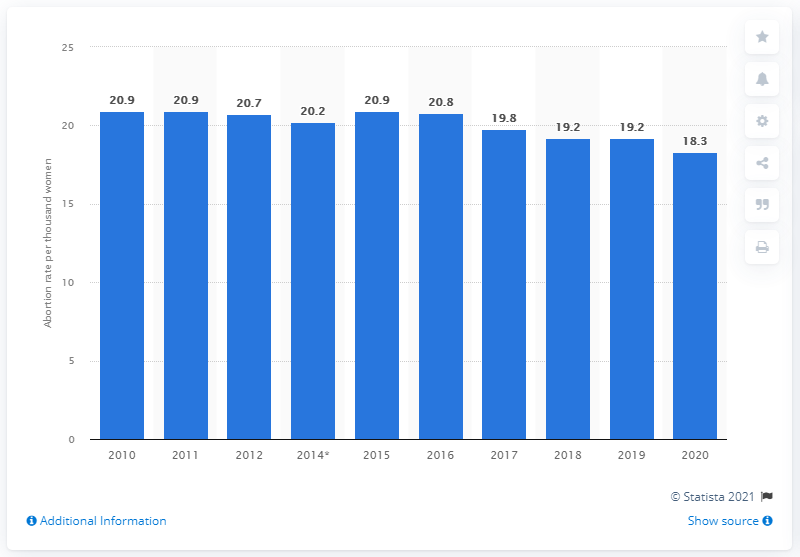Specify some key components in this picture. According to recent statistics, the highest abortion rate in Sweden is approximately 20.9 abortions per thousand women. According to data from 2020, the abortion rate in Sweden was 18.3 abortions per thousand women. 